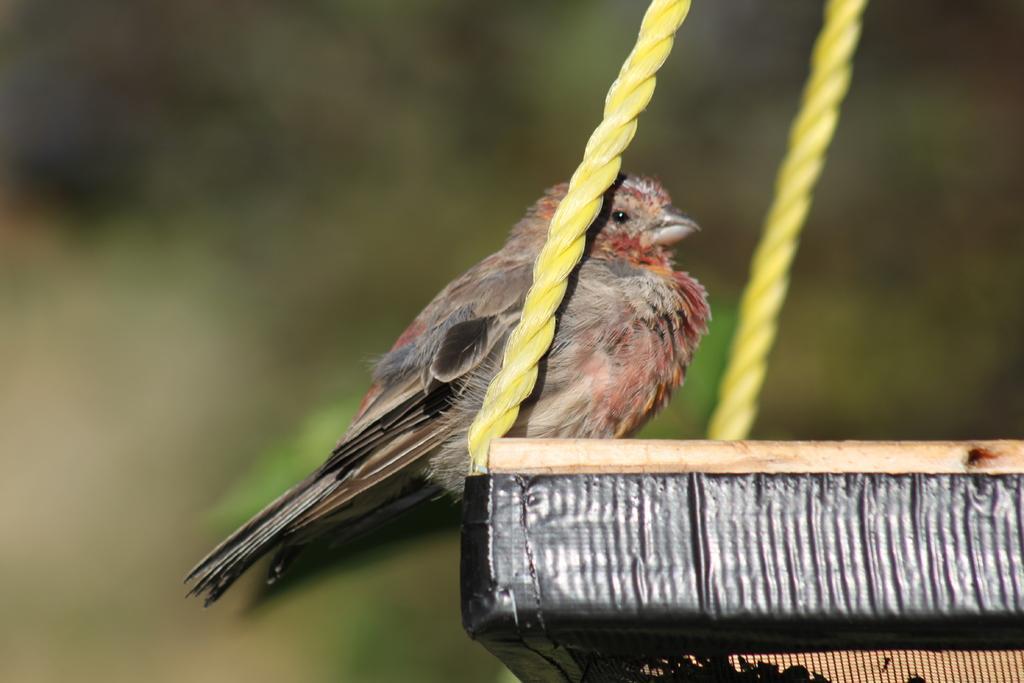How would you summarize this image in a sentence or two? In this picture we can see a bird on an object,here we can see ropes and in the background we can see it is blurry. 